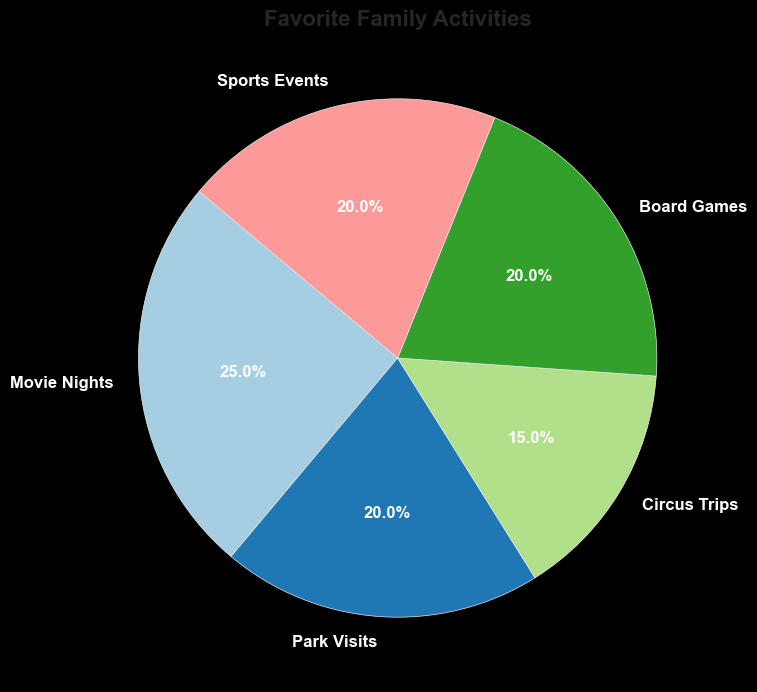Which activity is the most favorite among families? The activity with the highest percentage represents the most favorite among families. From the chart, Movie Nights has the highest percentage of 25%.
Answer: Movie Nights What is the total percentage of indoor activities? Indoor activities in the chart are Movie Nights and Board Games. Their percentages are 25% and 20%, respectively. Summing these gives 25% + 20% = 45%.
Answer: 45% Which activities have the same percentage? By comparing the percentages of all activities, we can see that Park Visits, Board Games, and Sports Events each have 20%.
Answer: Park Visits, Board Games, and Sports Events How much more popular are Movie Nights compared to Circus Trips? Movie Nights have a percentage of 25%, while Circus Trips have 15%. The difference can be calculated as 25% - 15% = 10%.
Answer: 10% What is the average percentage of Board Games and Sports Events? Both Board Games and Sports Events have a percentage of 20%. The average is calculated as (20% + 20%) / 2 = 20%.
Answer: 20% What percentage of activities are outdoor activities? Outdoor activities in the chart are Park Visits and Sports Events. Their percentages are 20% and 20%, respectively. Summing these gives 20% + 20% = 40%.
Answer: 40% Which activity has the smallest percentage? The activity with the smallest percentage in the chart is Circus Trips with 15%.
Answer: Circus Trips What is the combined percentage of the three least favorite activities? The three least favorite activities are those with the lowest percentages: Circus Trips (15%), Park Visits (20%), and Sports Events (20%). Summing these gives 15% + 20% + 20% = 55%.
Answer: 55% What is the central angle for the Sports Events section in the pie chart? The central angle for a section of a pie chart can be calculated using its percentage. The formula is (Percentage / 100) * 360 degrees. For Sports Events: (20 / 100) * 360 = 72 degrees.
Answer: 72 degrees 